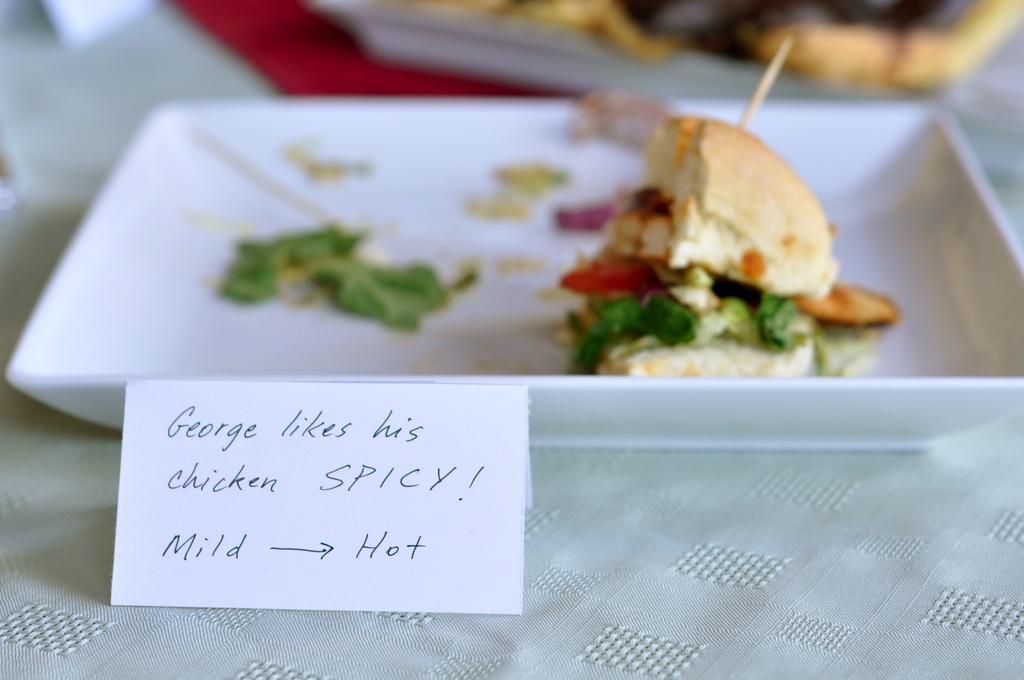Describe this image in one or two sentences. There are some texts written on the white color card which is arranged on the table which is covered with a cloth on which, there is a white color tray which is having a sandwich. And there are other objects. 